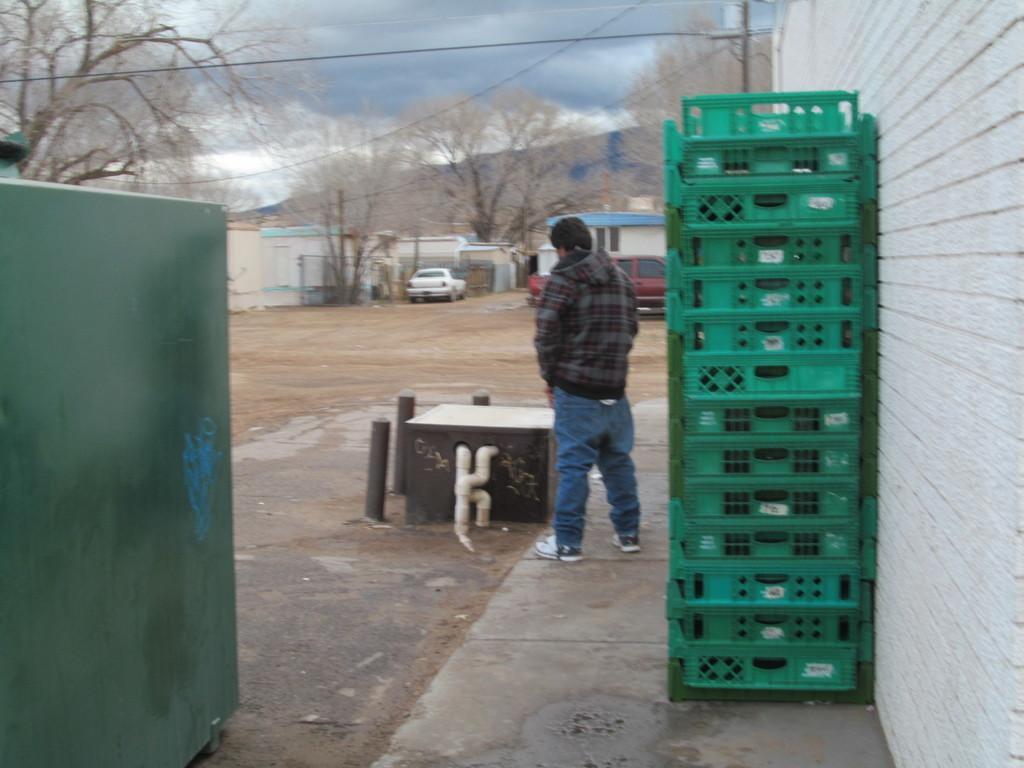How would you summarize this image in a sentence or two? On the right side there is a wall. Near to that there are boxes. And one person is stand. Near to the person there is a block. Near to the block there are small poles. On the left side there is a wall. In the background there are trees, buildings, vehicles and sky with clouds. 